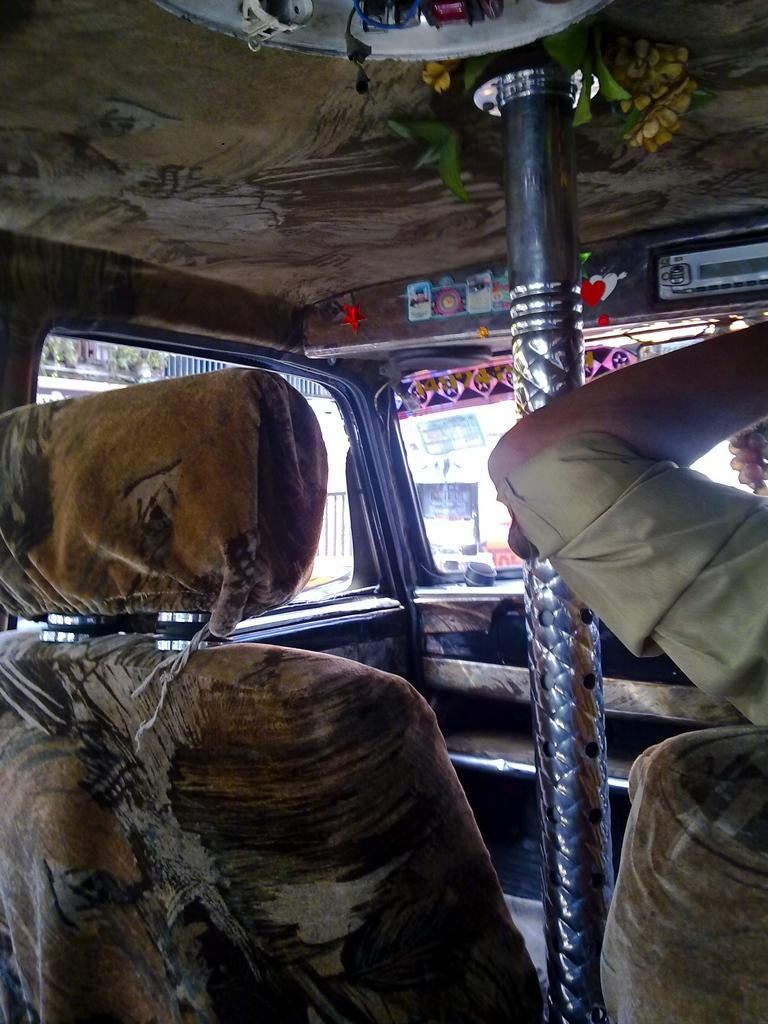What is the setting of the image? The image is taken inside a vehicle. What can be found inside the vehicle? There are seats and a rod visible in the vehicle. Is there any indication of a person in the image? Yes, a person's hand is visible to the right. What allows the occupants to see outside the vehicle? There is a glass (window) in the vehicle. Is there any artwork (art) visible on the walls of the vehicle? There is no mention of artwork or any decorations on the walls of the vehicle in the provided facts. Can you see any cobwebs in the image? There is no mention of cobwebs in the provided facts, and they are not visible in the image. 